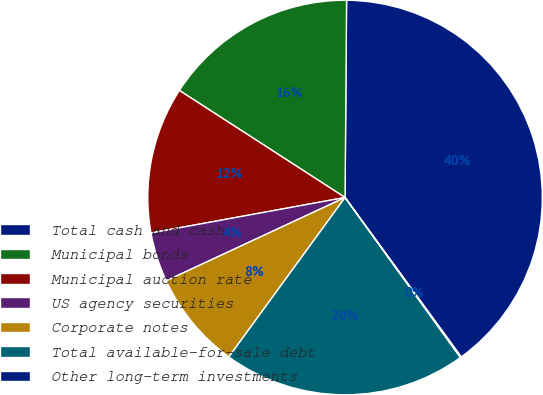Convert chart. <chart><loc_0><loc_0><loc_500><loc_500><pie_chart><fcel>Total cash and cash<fcel>Municipal bonds<fcel>Municipal auction rate<fcel>US agency securities<fcel>Corporate notes<fcel>Total available-for-sale debt<fcel>Other long-term investments<nl><fcel>39.86%<fcel>15.99%<fcel>12.01%<fcel>4.06%<fcel>8.04%<fcel>19.97%<fcel>0.08%<nl></chart> 